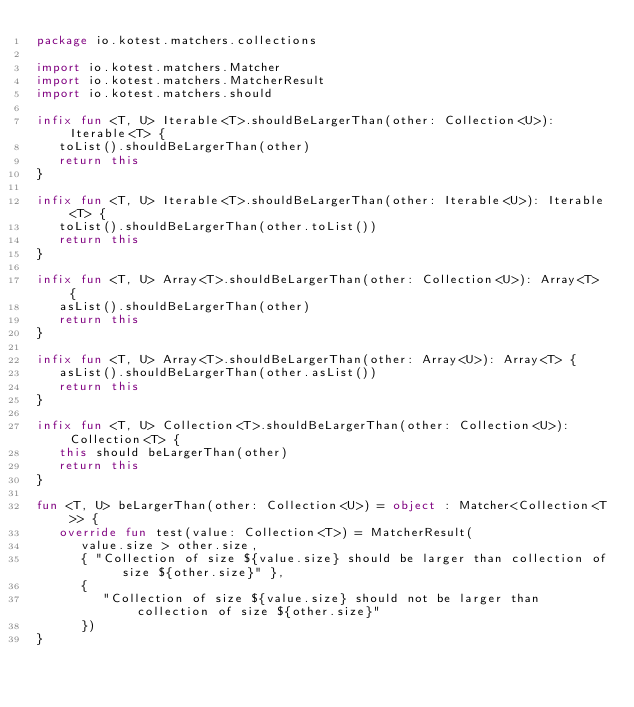<code> <loc_0><loc_0><loc_500><loc_500><_Kotlin_>package io.kotest.matchers.collections

import io.kotest.matchers.Matcher
import io.kotest.matchers.MatcherResult
import io.kotest.matchers.should

infix fun <T, U> Iterable<T>.shouldBeLargerThan(other: Collection<U>): Iterable<T> {
   toList().shouldBeLargerThan(other)
   return this
}

infix fun <T, U> Iterable<T>.shouldBeLargerThan(other: Iterable<U>): Iterable<T> {
   toList().shouldBeLargerThan(other.toList())
   return this
}

infix fun <T, U> Array<T>.shouldBeLargerThan(other: Collection<U>): Array<T> {
   asList().shouldBeLargerThan(other)
   return this
}

infix fun <T, U> Array<T>.shouldBeLargerThan(other: Array<U>): Array<T> {
   asList().shouldBeLargerThan(other.asList())
   return this
}

infix fun <T, U> Collection<T>.shouldBeLargerThan(other: Collection<U>): Collection<T> {
   this should beLargerThan(other)
   return this
}

fun <T, U> beLargerThan(other: Collection<U>) = object : Matcher<Collection<T>> {
   override fun test(value: Collection<T>) = MatcherResult(
      value.size > other.size,
      { "Collection of size ${value.size} should be larger than collection of size ${other.size}" },
      {
         "Collection of size ${value.size} should not be larger than collection of size ${other.size}"
      })
}
</code> 